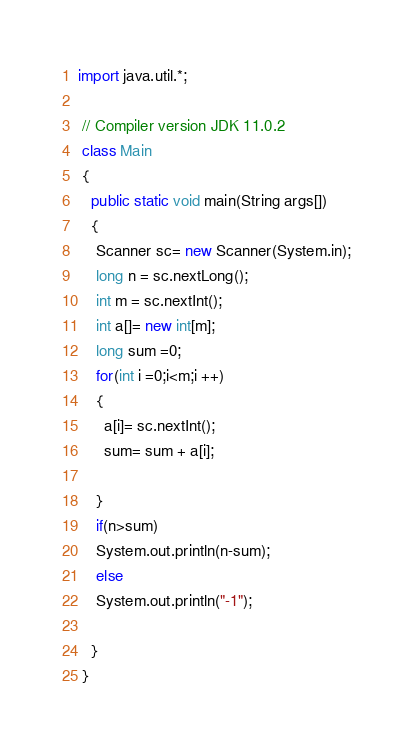Convert code to text. <code><loc_0><loc_0><loc_500><loc_500><_Java_>import java.util.*;

 // Compiler version JDK 11.0.2
 class Main
 {
   public static void main(String args[])
   { 
    Scanner sc= new Scanner(System.in);
    long n = sc.nextLong();
    int m = sc.nextInt();
    int a[]= new int[m];
    long sum =0;
    for(int i =0;i<m;i ++)
    {
      a[i]= sc.nextInt();
      sum= sum + a[i];
      
    }
    if(n>sum)
    System.out.println(n-sum);
    else
    System.out.println("-1");
    
   }
 }</code> 